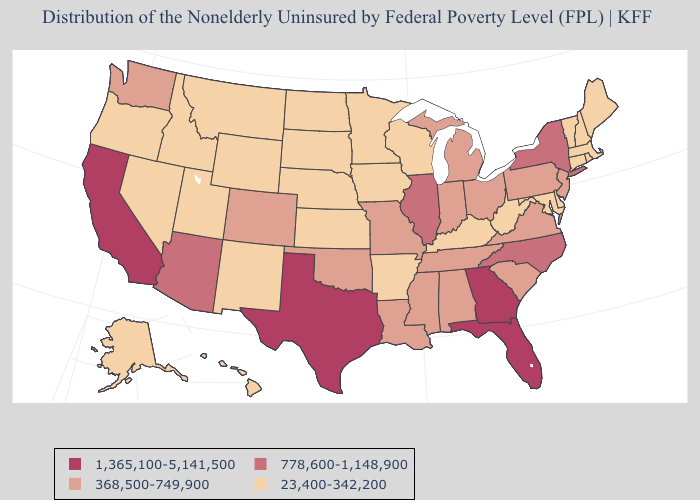How many symbols are there in the legend?
Write a very short answer. 4. Does the first symbol in the legend represent the smallest category?
Short answer required. No. What is the lowest value in states that border New Hampshire?
Concise answer only. 23,400-342,200. Name the states that have a value in the range 778,600-1,148,900?
Short answer required. Arizona, Illinois, New York, North Carolina. What is the highest value in the MidWest ?
Quick response, please. 778,600-1,148,900. Name the states that have a value in the range 23,400-342,200?
Give a very brief answer. Alaska, Arkansas, Connecticut, Delaware, Hawaii, Idaho, Iowa, Kansas, Kentucky, Maine, Maryland, Massachusetts, Minnesota, Montana, Nebraska, Nevada, New Hampshire, New Mexico, North Dakota, Oregon, Rhode Island, South Dakota, Utah, Vermont, West Virginia, Wisconsin, Wyoming. What is the value of Missouri?
Give a very brief answer. 368,500-749,900. Does Wisconsin have the highest value in the USA?
Keep it brief. No. How many symbols are there in the legend?
Keep it brief. 4. What is the value of Oklahoma?
Concise answer only. 368,500-749,900. Does Tennessee have the highest value in the USA?
Give a very brief answer. No. Does North Carolina have a lower value than Florida?
Be succinct. Yes. Does the first symbol in the legend represent the smallest category?
Be succinct. No. What is the value of Michigan?
Concise answer only. 368,500-749,900. 